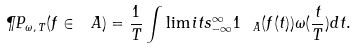<formula> <loc_0><loc_0><loc_500><loc_500>\P P _ { \omega , \, T } ( f \in \ A ) = \frac { 1 } { T } \int \lim i t s _ { - \infty } ^ { \infty } 1 _ { \ A } ( f ( t ) ) \omega ( \frac { t } { T } ) d t .</formula> 